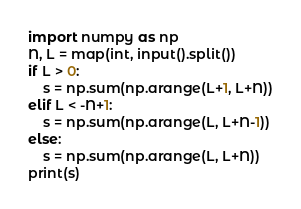<code> <loc_0><loc_0><loc_500><loc_500><_Python_>import numpy as np
N, L = map(int, input().split())
if L > 0:
    s = np.sum(np.arange(L+1, L+N))
elif L < -N+1:
    s = np.sum(np.arange(L, L+N-1))
else:
    s = np.sum(np.arange(L, L+N))
print(s)</code> 